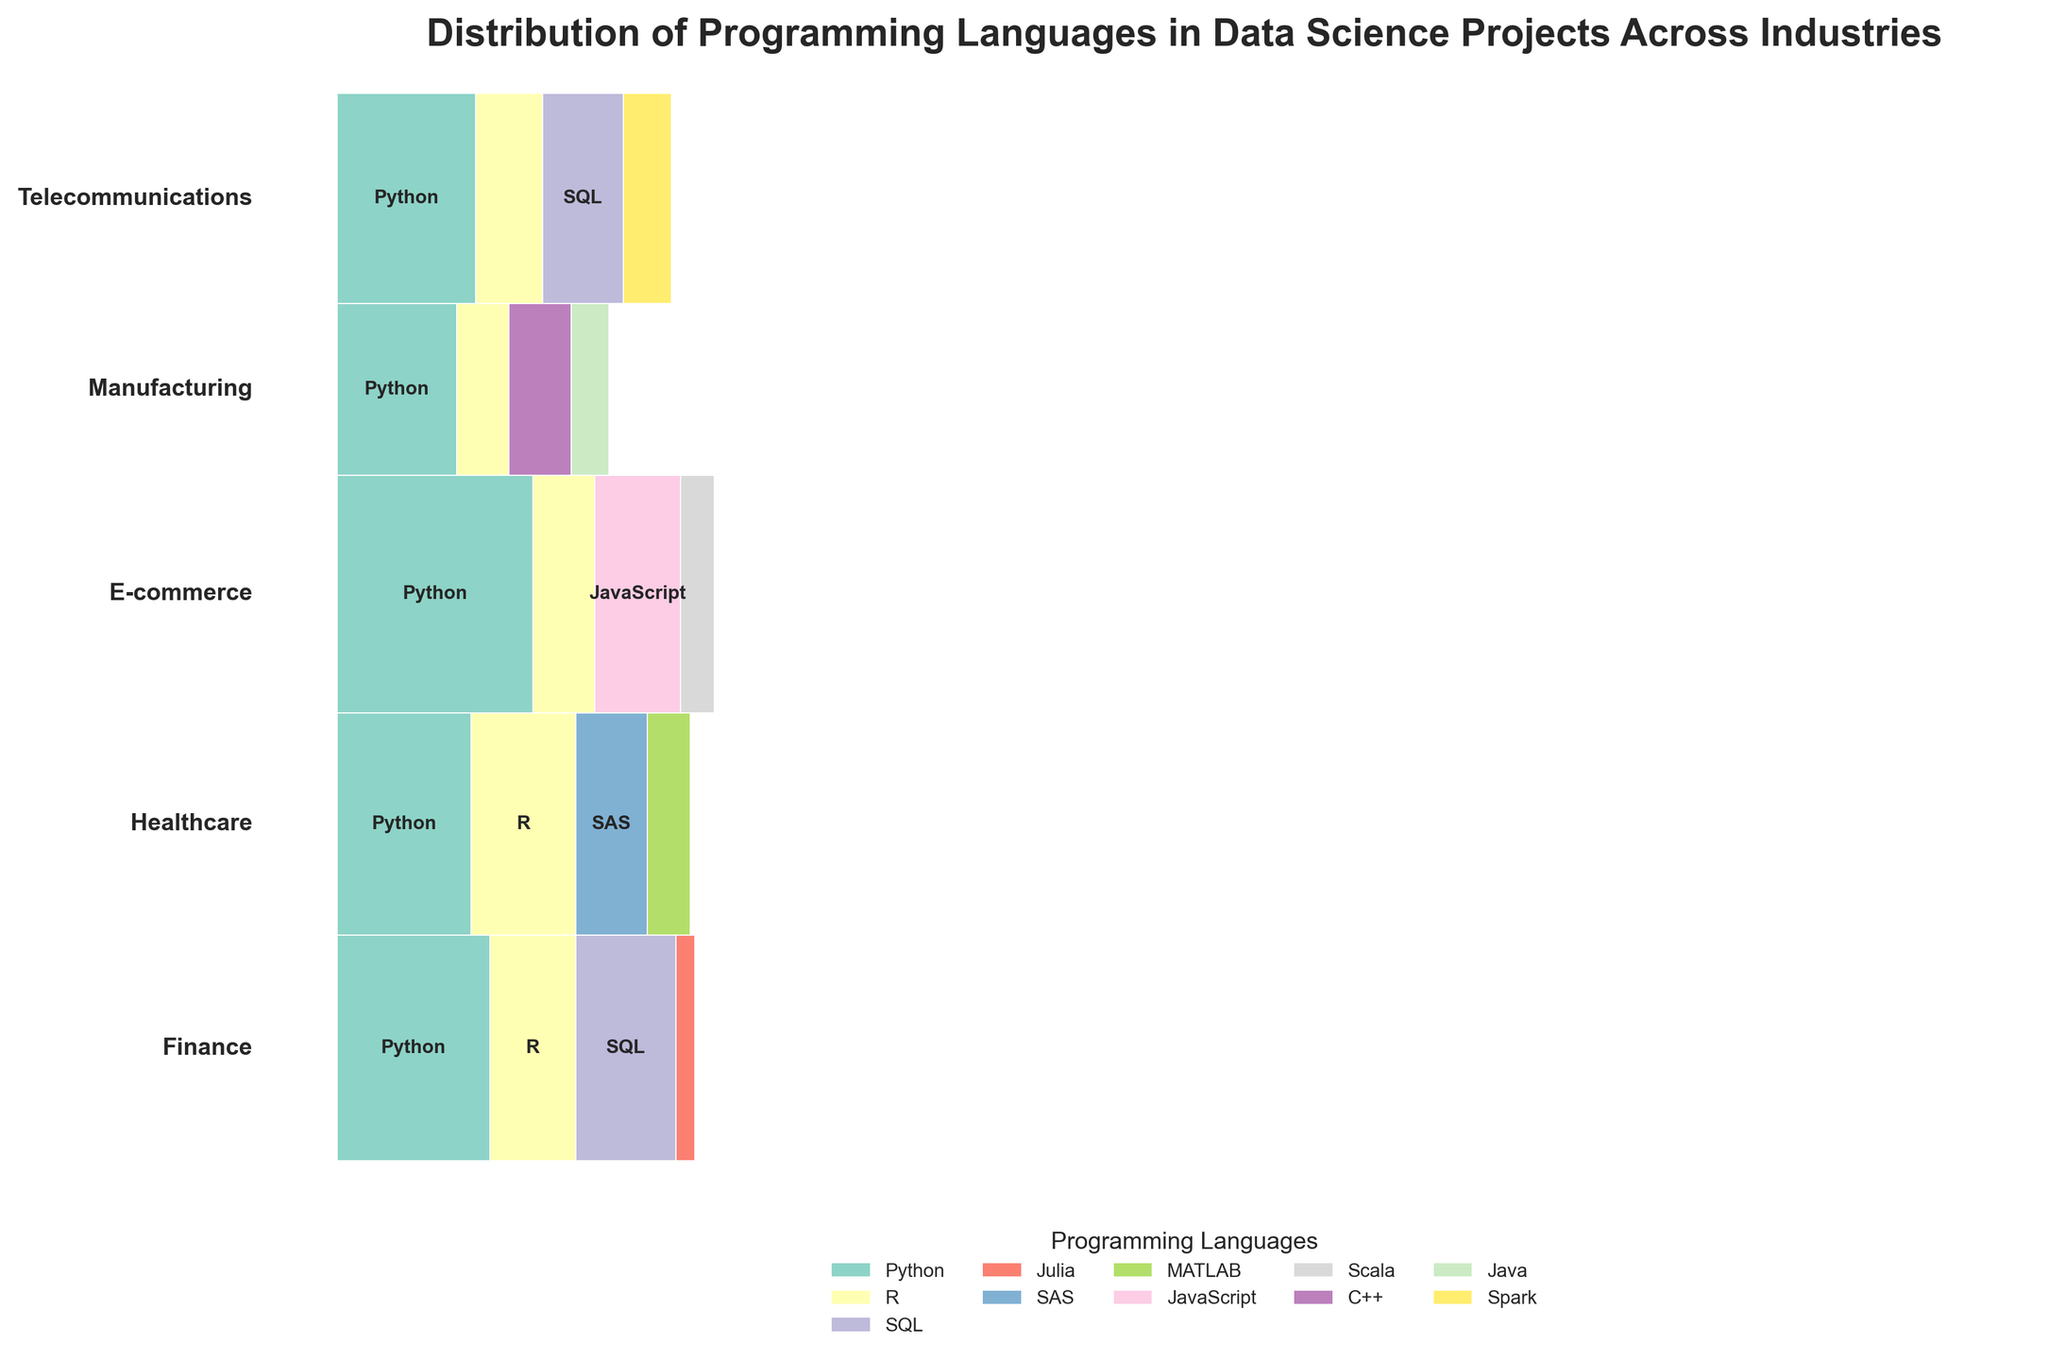What is the title of the plot? The title is prominently displayed at the top of the plot. It reads 'Distribution of Programming Languages in Data Science Projects Across Industries'.
Answer: Distribution of Programming Languages in Data Science Projects Across Industries How many different industries are represented? Look at the vertical axis labels on the left side of the plot to see the unique industry names displayed.
Answer: 5 Which programming language is most used in the Finance industry? In the section labeled 'Finance', the largest rectangle corresponds to the programming language 'Python'.
Answer: Python Which industry has the highest overall number of data science projects? By comparing the overall heights of the sections labeled for each industry, the section labeled 'E-commerce' has the largest height, indicating the most projects.
Answer: E-commerce How does the usage of Python compare between the Healthcare and Telecommunications industries? In the sections labeled 'Healthcare' and 'Telecommunications', compare the width of the rectangles for 'Python'. Both are quite significant but slightly narrower in 'Telecommunications'.
Answer: Higher in Healthcare What is the combined total width of the rectangles for Python projects across all industries? Sum the widths of the 'Python' rectangles across all industries to find the combined total. In the plot, widths directly correspond to proportional project counts.
Answer: Higher than 0.5 Which programming language is exclusively used in the Healthcare industry? Look for a unique language rectangle in the 'Healthcare' section that doesn't appear in other industries’ sections. 'SAS' and 'MATLAB' are only present in Healthcare.
Answer: SAS, MATLAB In which industries does the 'R' programming language appear? Look at the rectangles for 'R' and identify the industries they belong to. It's used in Finance, Healthcare, E-commerce, Manufacturing, and Telecommunications.
Answer: Finance, Healthcare, E-commerce, Manufacturing, Telecommunications Compare the use of SQL between Finance and Telecommunications industries. Compare the rectangles labeled 'SQL' in both Finance and Telecommunications. Their widths give an indication of the number of projects. 'SQL' appears wider in Telecommunications.
Answer: More in Telecommunications Which industry uses the widest variety of programming languages? Count the number of different labeled rectangles within each industry's section. The industry with the most unique labels has the widest variety of programming languages. 'Healthcare' and 'E-commerce' both have four distinct languages.
Answer: Healthcare, E-commerce 